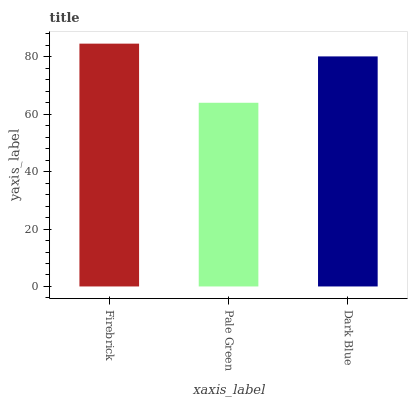Is Pale Green the minimum?
Answer yes or no. Yes. Is Firebrick the maximum?
Answer yes or no. Yes. Is Dark Blue the minimum?
Answer yes or no. No. Is Dark Blue the maximum?
Answer yes or no. No. Is Dark Blue greater than Pale Green?
Answer yes or no. Yes. Is Pale Green less than Dark Blue?
Answer yes or no. Yes. Is Pale Green greater than Dark Blue?
Answer yes or no. No. Is Dark Blue less than Pale Green?
Answer yes or no. No. Is Dark Blue the high median?
Answer yes or no. Yes. Is Dark Blue the low median?
Answer yes or no. Yes. Is Pale Green the high median?
Answer yes or no. No. Is Pale Green the low median?
Answer yes or no. No. 